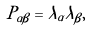Convert formula to latex. <formula><loc_0><loc_0><loc_500><loc_500>P _ { \alpha \beta } = \lambda _ { \alpha } \lambda _ { \beta } ,</formula> 